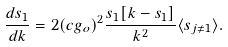<formula> <loc_0><loc_0><loc_500><loc_500>\frac { d s _ { 1 } } { d k } = 2 ( c g _ { o } ) ^ { 2 } \frac { s _ { 1 } [ k - s _ { 1 } ] } { k ^ { 2 } } \langle s _ { j \neq 1 } \rangle .</formula> 